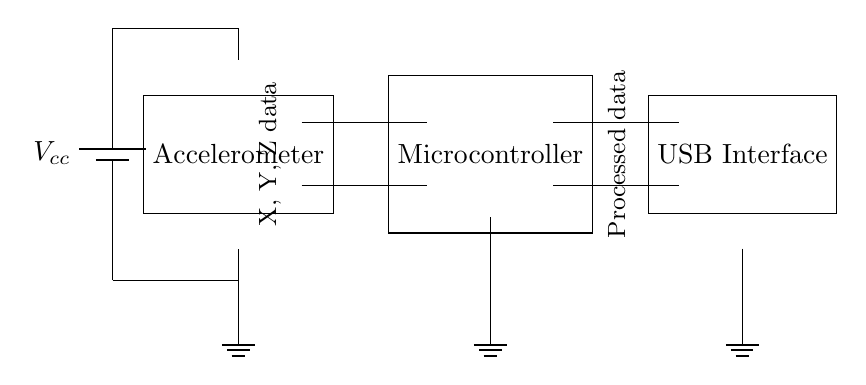What is the main component that detects head movements? The main component that detects head movements is the accelerometer, which is labeled in the diagram. It receives input about the orientation changes in the X, Y, and Z axes.
Answer: Accelerometer What does the USB interface do? The USB interface in the circuit processes the data received from the microcontroller and allows the device to communicate with a computer or a host system.
Answer: Processed data How many connection points does the microcontroller have? The microcontroller shows two connection points, one for each data line to the USB interface. It connects with two different lines from the accelerometer for processing data.
Answer: Two What is the role of the power supply? The power supply provides the necessary voltage to all components in the circuit. It ensures that the accelerometer and microcontroller operate correctly by supplying the voltage required for their functioning.
Answer: Power supply What type of data does the accelerometer output? The accelerometer outputs motion data, specifically data related to movement along the X, Y, and Z axes, which is crucial for detecting orientation changes.
Answer: X, Y, Z data Where do the ground connections lead in the circuit? The ground connections lead to the ground node in the circuit, which is a reference point for voltage levels and ensures stability in the circuit’s operation. Each component is connected to this ground.
Answer: Ground node What happens to the data from the accelerometer? The data from the accelerometer is sent to the microcontroller, which processes it and then outputs it to the USB interface to be communicated or utilized by another device.
Answer: Processed data 